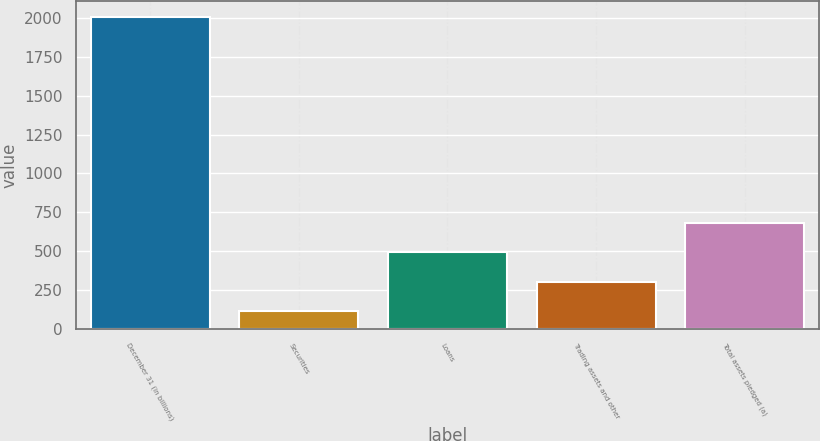Convert chart. <chart><loc_0><loc_0><loc_500><loc_500><bar_chart><fcel>December 31 (in billions)<fcel>Securities<fcel>Loans<fcel>Trading assets and other<fcel>Total assets pledged (a)<nl><fcel>2010<fcel>112.1<fcel>491.68<fcel>301.89<fcel>681.47<nl></chart> 